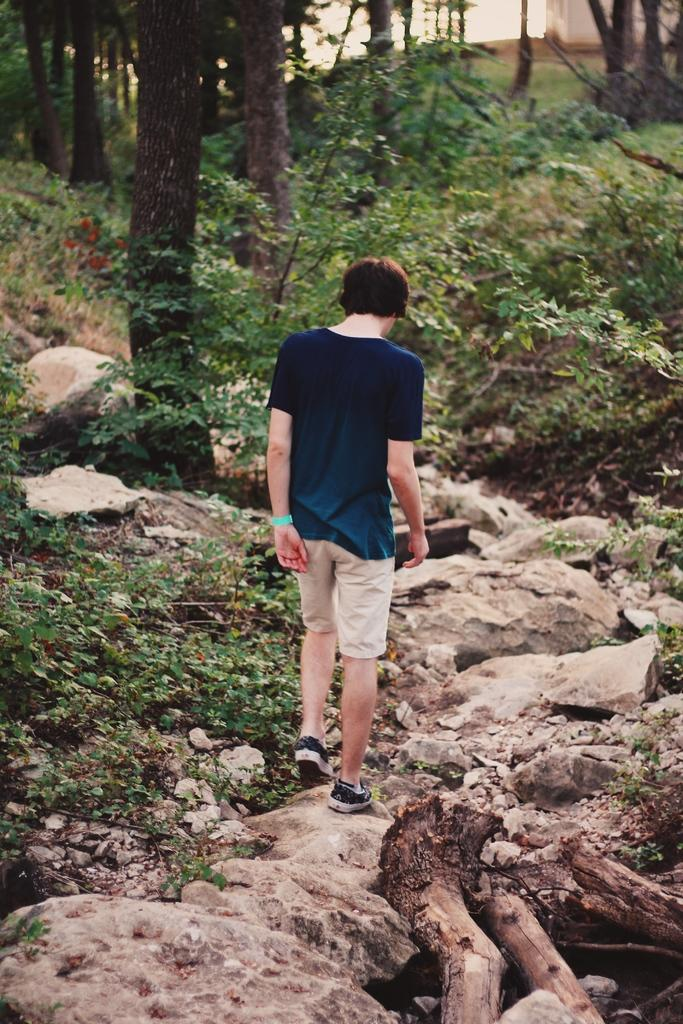Who is the main subject in the image? There is a boy in the image. What is the boy wearing? The boy is wearing a blue t-shirt and shorts. Where is the boy standing? The boy is standing on rocks. What can be seen in the background of the image? There are plants and a tree trunk visible in the background. What type of fang can be seen in the image? There is no fang present in the image. How many horses are visible in the image? There are no horses present in the image. 